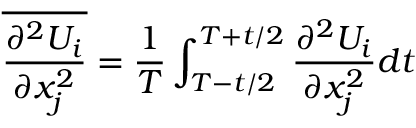<formula> <loc_0><loc_0><loc_500><loc_500>\overline { { \frac { \partial ^ { 2 } U _ { i } } { \partial x _ { j } ^ { 2 } } } } = { \frac { 1 } { T } } \int _ { T - t / 2 } ^ { T + t / 2 } { \frac { \partial ^ { 2 } U _ { i } } { \partial x _ { j } ^ { 2 } } } d t</formula> 